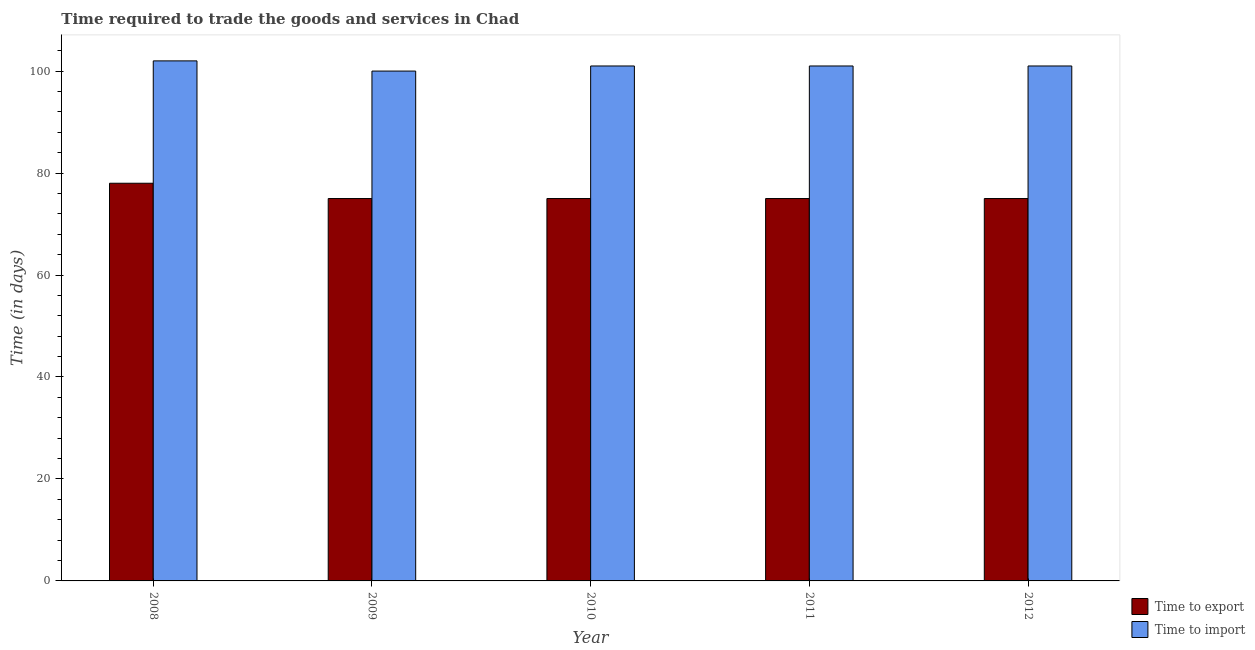Are the number of bars per tick equal to the number of legend labels?
Provide a succinct answer. Yes. How many bars are there on the 4th tick from the left?
Offer a terse response. 2. How many bars are there on the 5th tick from the right?
Ensure brevity in your answer.  2. In how many cases, is the number of bars for a given year not equal to the number of legend labels?
Ensure brevity in your answer.  0. What is the time to import in 2011?
Offer a terse response. 101. Across all years, what is the maximum time to export?
Your response must be concise. 78. Across all years, what is the minimum time to export?
Your answer should be very brief. 75. In which year was the time to import maximum?
Offer a very short reply. 2008. What is the total time to import in the graph?
Make the answer very short. 505. What is the difference between the time to import in 2008 and the time to export in 2010?
Provide a short and direct response. 1. What is the average time to export per year?
Ensure brevity in your answer.  75.6. In how many years, is the time to export greater than 8 days?
Give a very brief answer. 5. What is the ratio of the time to import in 2008 to that in 2010?
Your answer should be compact. 1.01. Is the difference between the time to export in 2008 and 2010 greater than the difference between the time to import in 2008 and 2010?
Your answer should be compact. No. What is the difference between the highest and the second highest time to export?
Keep it short and to the point. 3. What is the difference between the highest and the lowest time to export?
Your response must be concise. 3. Is the sum of the time to export in 2008 and 2010 greater than the maximum time to import across all years?
Provide a succinct answer. Yes. What does the 1st bar from the left in 2011 represents?
Your answer should be compact. Time to export. What does the 1st bar from the right in 2009 represents?
Provide a succinct answer. Time to import. How many bars are there?
Your answer should be very brief. 10. How many legend labels are there?
Give a very brief answer. 2. What is the title of the graph?
Make the answer very short. Time required to trade the goods and services in Chad. What is the label or title of the Y-axis?
Provide a succinct answer. Time (in days). What is the Time (in days) in Time to import in 2008?
Offer a very short reply. 102. What is the Time (in days) of Time to export in 2010?
Offer a very short reply. 75. What is the Time (in days) in Time to import in 2010?
Provide a short and direct response. 101. What is the Time (in days) in Time to export in 2011?
Keep it short and to the point. 75. What is the Time (in days) of Time to import in 2011?
Make the answer very short. 101. What is the Time (in days) in Time to import in 2012?
Make the answer very short. 101. Across all years, what is the maximum Time (in days) of Time to import?
Make the answer very short. 102. What is the total Time (in days) of Time to export in the graph?
Your answer should be compact. 378. What is the total Time (in days) of Time to import in the graph?
Provide a short and direct response. 505. What is the difference between the Time (in days) in Time to import in 2008 and that in 2010?
Offer a very short reply. 1. What is the difference between the Time (in days) in Time to import in 2008 and that in 2011?
Ensure brevity in your answer.  1. What is the difference between the Time (in days) of Time to export in 2008 and that in 2012?
Give a very brief answer. 3. What is the difference between the Time (in days) in Time to export in 2009 and that in 2010?
Provide a succinct answer. 0. What is the difference between the Time (in days) of Time to export in 2009 and that in 2012?
Offer a very short reply. 0. What is the difference between the Time (in days) in Time to import in 2010 and that in 2011?
Offer a terse response. 0. What is the difference between the Time (in days) of Time to export in 2010 and that in 2012?
Your answer should be compact. 0. What is the difference between the Time (in days) in Time to import in 2010 and that in 2012?
Your answer should be compact. 0. What is the difference between the Time (in days) in Time to export in 2011 and that in 2012?
Ensure brevity in your answer.  0. What is the difference between the Time (in days) in Time to import in 2011 and that in 2012?
Provide a short and direct response. 0. What is the difference between the Time (in days) of Time to export in 2008 and the Time (in days) of Time to import in 2009?
Offer a very short reply. -22. What is the difference between the Time (in days) of Time to export in 2008 and the Time (in days) of Time to import in 2010?
Your answer should be very brief. -23. What is the difference between the Time (in days) of Time to export in 2008 and the Time (in days) of Time to import in 2011?
Keep it short and to the point. -23. What is the difference between the Time (in days) of Time to export in 2009 and the Time (in days) of Time to import in 2011?
Provide a short and direct response. -26. What is the difference between the Time (in days) of Time to export in 2009 and the Time (in days) of Time to import in 2012?
Provide a short and direct response. -26. What is the difference between the Time (in days) in Time to export in 2010 and the Time (in days) in Time to import in 2012?
Keep it short and to the point. -26. What is the average Time (in days) in Time to export per year?
Keep it short and to the point. 75.6. What is the average Time (in days) of Time to import per year?
Offer a terse response. 101. In the year 2010, what is the difference between the Time (in days) of Time to export and Time (in days) of Time to import?
Offer a very short reply. -26. In the year 2012, what is the difference between the Time (in days) of Time to export and Time (in days) of Time to import?
Your response must be concise. -26. What is the ratio of the Time (in days) of Time to import in 2008 to that in 2009?
Keep it short and to the point. 1.02. What is the ratio of the Time (in days) of Time to export in 2008 to that in 2010?
Provide a short and direct response. 1.04. What is the ratio of the Time (in days) in Time to import in 2008 to that in 2010?
Provide a short and direct response. 1.01. What is the ratio of the Time (in days) of Time to import in 2008 to that in 2011?
Your response must be concise. 1.01. What is the ratio of the Time (in days) of Time to import in 2008 to that in 2012?
Provide a succinct answer. 1.01. What is the ratio of the Time (in days) of Time to import in 2009 to that in 2010?
Your response must be concise. 0.99. What is the ratio of the Time (in days) in Time to export in 2009 to that in 2012?
Offer a terse response. 1. What is the ratio of the Time (in days) in Time to export in 2010 to that in 2011?
Your answer should be compact. 1. What is the ratio of the Time (in days) of Time to export in 2011 to that in 2012?
Give a very brief answer. 1. What is the ratio of the Time (in days) in Time to import in 2011 to that in 2012?
Give a very brief answer. 1. What is the difference between the highest and the second highest Time (in days) of Time to import?
Your answer should be very brief. 1. 